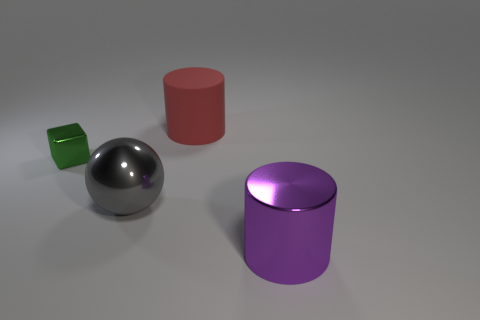There is a metal thing that is on the right side of the gray metal sphere; what is its shape? cylinder 